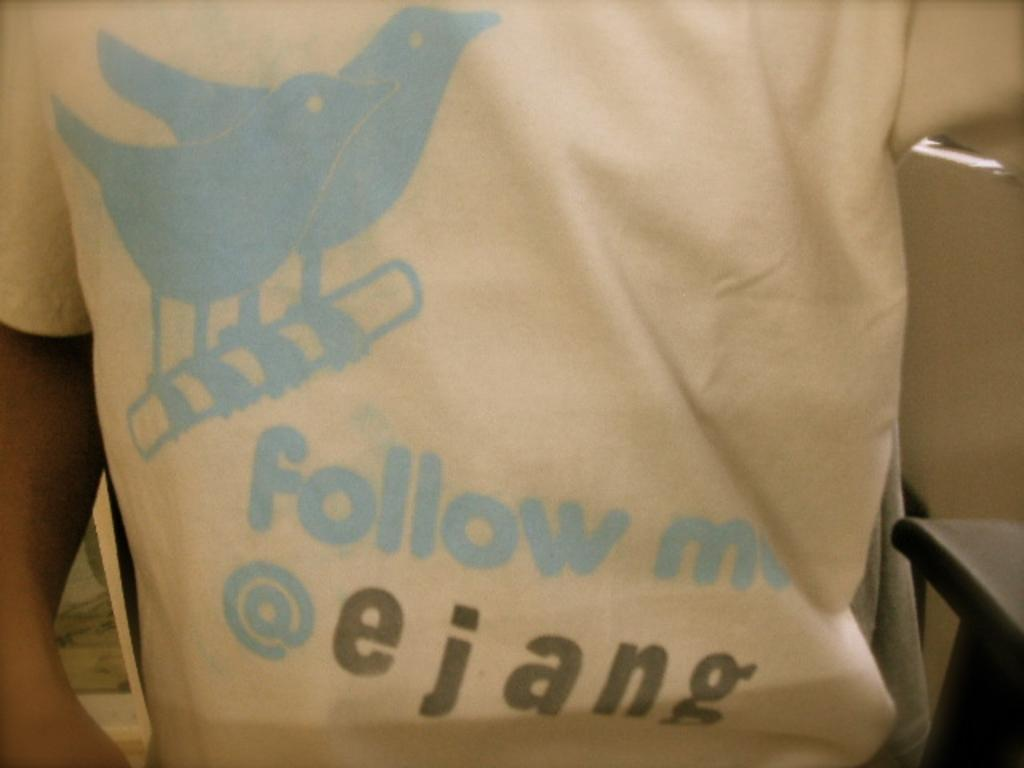What is the main subject in the foreground of the image? There is a person in the foreground of the image. What type of clothing is the person wearing? The person is wearing a t-shirt. Is there any text or design on the t-shirt? Yes, there is text written on the t-shirt. What type of jar is visible in the image? There is no jar present in the image. What season is depicted in the image? The provided facts do not mention any season or weather-related details, so it cannot be determined from the image. 